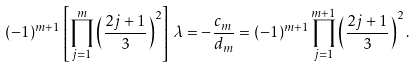Convert formula to latex. <formula><loc_0><loc_0><loc_500><loc_500>( - 1 ) ^ { m + 1 } \left [ \prod _ { j = 1 } ^ { m } \left ( \frac { 2 j + 1 } 3 \right ) ^ { 2 } \right ] \, \lambda = - \frac { c _ { m } } { d _ { m } } = ( - 1 ) ^ { m + 1 } \prod _ { j = 1 } ^ { m + 1 } \left ( \frac { 2 j + 1 } 3 \right ) ^ { 2 } .</formula> 